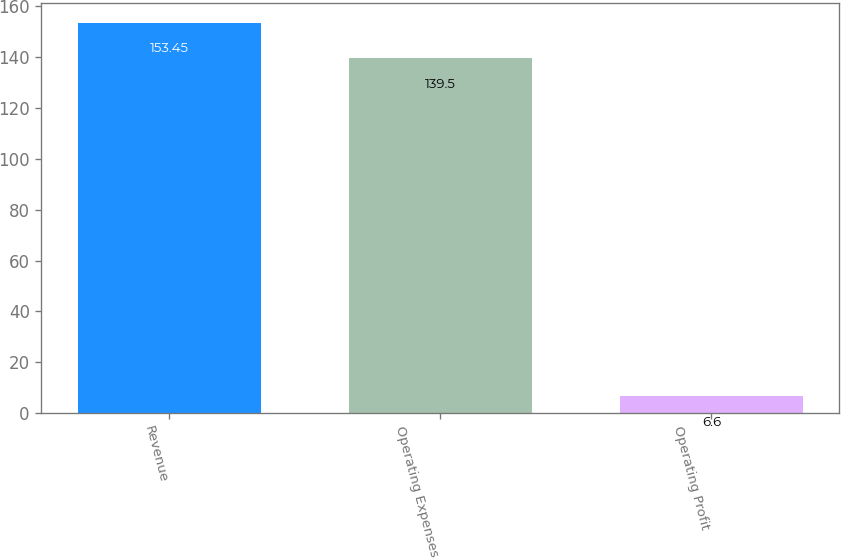Convert chart. <chart><loc_0><loc_0><loc_500><loc_500><bar_chart><fcel>Revenue<fcel>Operating Expenses<fcel>Operating Profit<nl><fcel>153.45<fcel>139.5<fcel>6.6<nl></chart> 